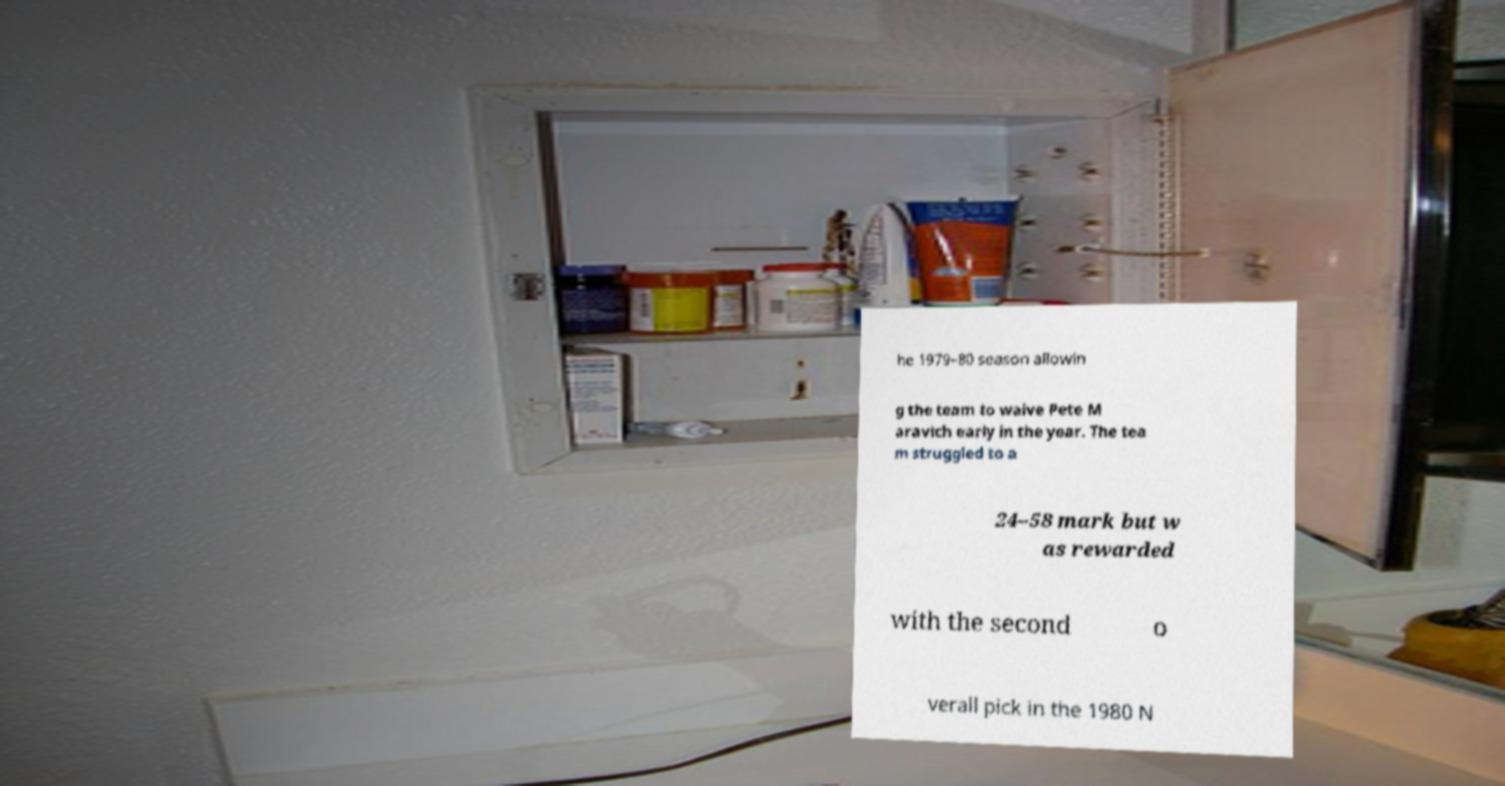Please identify and transcribe the text found in this image. he 1979–80 season allowin g the team to waive Pete M aravich early in the year. The tea m struggled to a 24–58 mark but w as rewarded with the second o verall pick in the 1980 N 